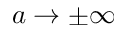Convert formula to latex. <formula><loc_0><loc_0><loc_500><loc_500>a \rightarrow \pm \infty</formula> 